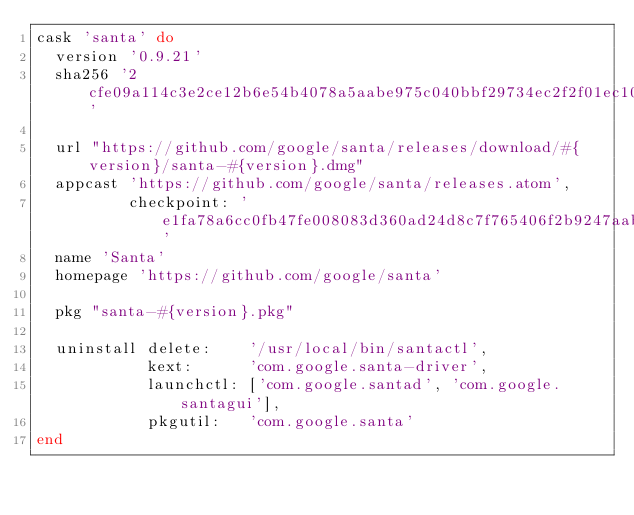<code> <loc_0><loc_0><loc_500><loc_500><_Ruby_>cask 'santa' do
  version '0.9.21'
  sha256 '2cfe09a114c3e2ce12b6e54b4078a5aabe975c040bbf29734ec2f2f01ec10a56'

  url "https://github.com/google/santa/releases/download/#{version}/santa-#{version}.dmg"
  appcast 'https://github.com/google/santa/releases.atom',
          checkpoint: 'e1fa78a6cc0fb47fe008083d360ad24d8c7f765406f2b9247aab4b311f9e178e'
  name 'Santa'
  homepage 'https://github.com/google/santa'

  pkg "santa-#{version}.pkg"

  uninstall delete:    '/usr/local/bin/santactl',
            kext:      'com.google.santa-driver',
            launchctl: ['com.google.santad', 'com.google.santagui'],
            pkgutil:   'com.google.santa'
end
</code> 